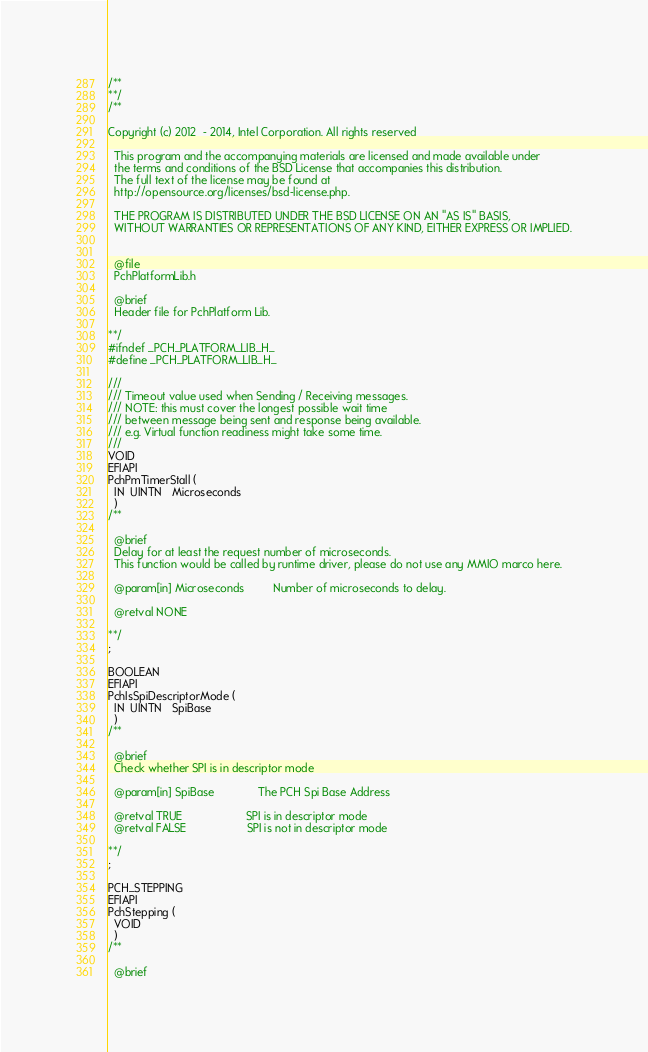Convert code to text. <code><loc_0><loc_0><loc_500><loc_500><_C_>/**
**/
/**

Copyright (c) 2012  - 2014, Intel Corporation. All rights reserved

  This program and the accompanying materials are licensed and made available under
  the terms and conditions of the BSD License that accompanies this distribution.
  The full text of the license may be found at
  http://opensource.org/licenses/bsd-license.php.

  THE PROGRAM IS DISTRIBUTED UNDER THE BSD LICENSE ON AN "AS IS" BASIS,
  WITHOUT WARRANTIES OR REPRESENTATIONS OF ANY KIND, EITHER EXPRESS OR IMPLIED.


  @file
  PchPlatformLib.h

  @brief
  Header file for PchPlatform Lib.

**/
#ifndef _PCH_PLATFORM_LIB_H_
#define _PCH_PLATFORM_LIB_H_

///
/// Timeout value used when Sending / Receiving messages.
/// NOTE: this must cover the longest possible wait time
/// between message being sent and response being available.
/// e.g. Virtual function readiness might take some time.
///
VOID
EFIAPI
PchPmTimerStall (
  IN  UINTN   Microseconds
  )
/**

  @brief
  Delay for at least the request number of microseconds.
  This function would be called by runtime driver, please do not use any MMIO marco here.

  @param[in] Microseconds         Number of microseconds to delay.

  @retval NONE

**/
;

BOOLEAN
EFIAPI
PchIsSpiDescriptorMode (
  IN  UINTN   SpiBase
  )
/**

  @brief
  Check whether SPI is in descriptor mode

  @param[in] SpiBase              The PCH Spi Base Address

  @retval TRUE                    SPI is in descriptor mode
  @retval FALSE                   SPI is not in descriptor mode

**/
;

PCH_STEPPING
EFIAPI
PchStepping (
  VOID
  )
/**

  @brief</code> 